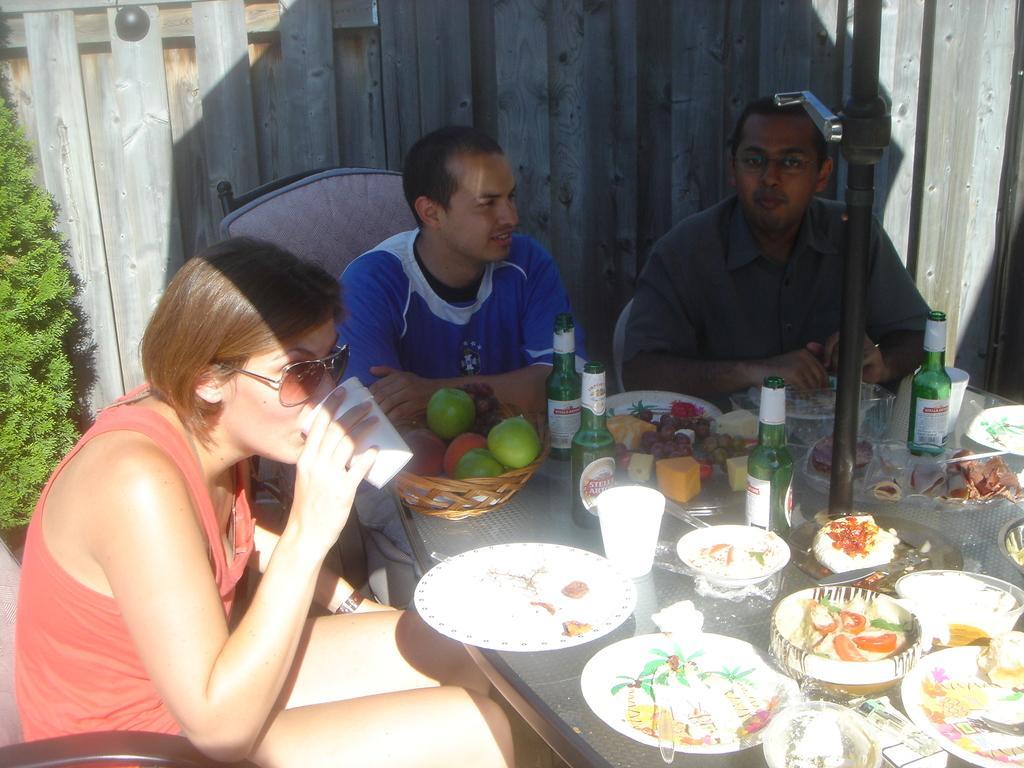Please provide a concise description of this image. In this image we can see three persons sitting on chairs on the sides of the table. On the table we can see fruits basket, beverage bottles, serving plates and desserts. In the background we can see wooden grill and a plant. 